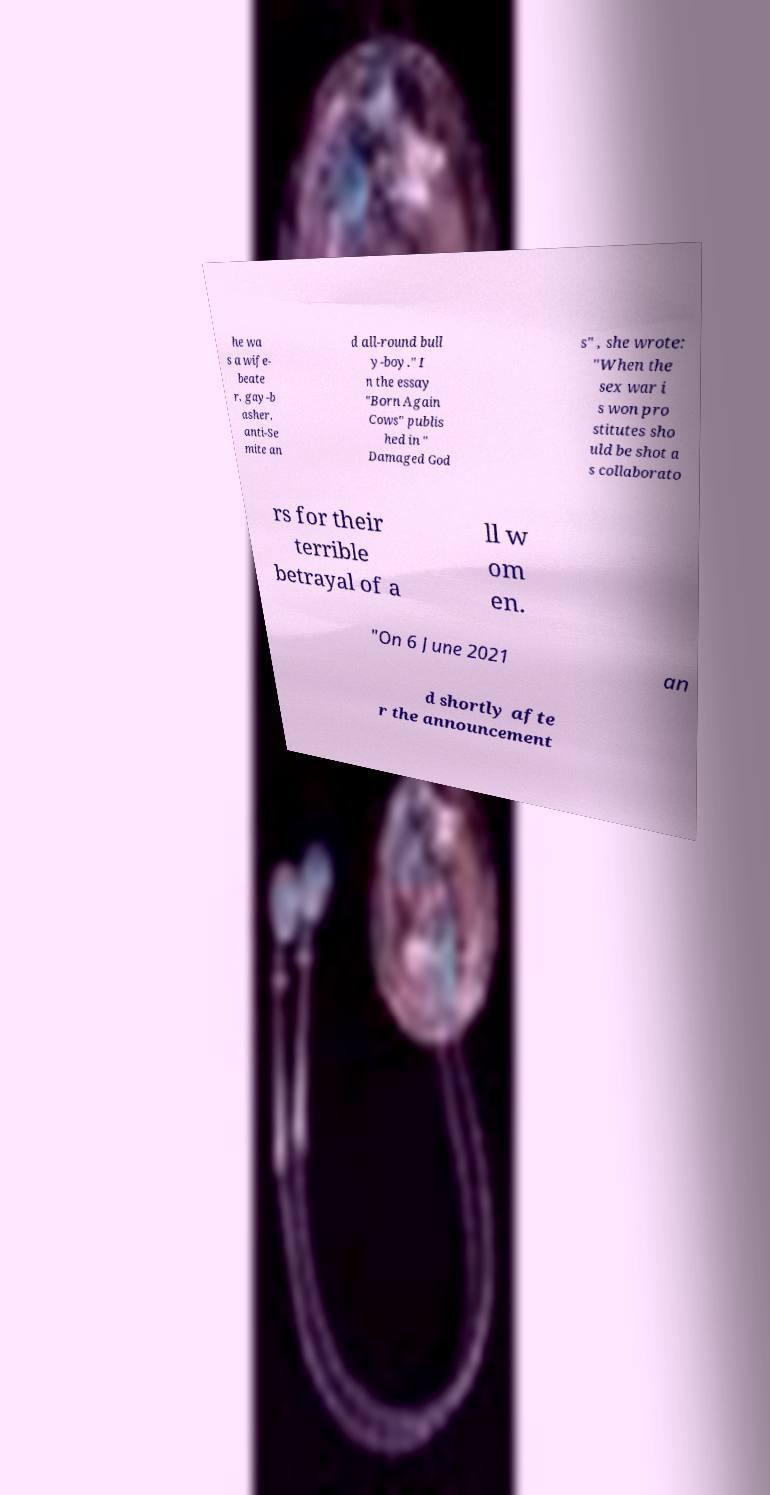There's text embedded in this image that I need extracted. Can you transcribe it verbatim? he wa s a wife- beate r, gay-b asher, anti-Se mite an d all-round bull y-boy." I n the essay "Born Again Cows" publis hed in " Damaged God s" , she wrote: "When the sex war i s won pro stitutes sho uld be shot a s collaborato rs for their terrible betrayal of a ll w om en. "On 6 June 2021 an d shortly afte r the announcement 